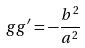Convert formula to latex. <formula><loc_0><loc_0><loc_500><loc_500>g g ^ { \prime } = - { \frac { b ^ { 2 } } { a ^ { 2 } } }</formula> 